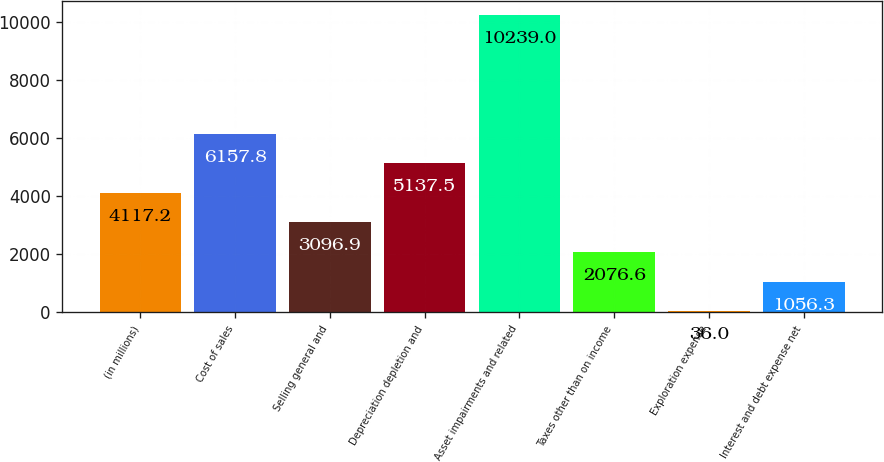Convert chart to OTSL. <chart><loc_0><loc_0><loc_500><loc_500><bar_chart><fcel>(in millions)<fcel>Cost of sales<fcel>Selling general and<fcel>Depreciation depletion and<fcel>Asset impairments and related<fcel>Taxes other than on income<fcel>Exploration expense<fcel>Interest and debt expense net<nl><fcel>4117.2<fcel>6157.8<fcel>3096.9<fcel>5137.5<fcel>10239<fcel>2076.6<fcel>36<fcel>1056.3<nl></chart> 